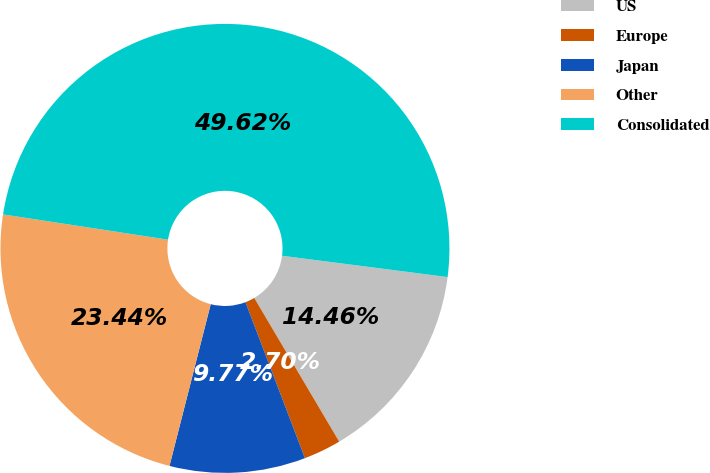Convert chart. <chart><loc_0><loc_0><loc_500><loc_500><pie_chart><fcel>US<fcel>Europe<fcel>Japan<fcel>Other<fcel>Consolidated<nl><fcel>14.46%<fcel>2.7%<fcel>9.77%<fcel>23.44%<fcel>49.61%<nl></chart> 